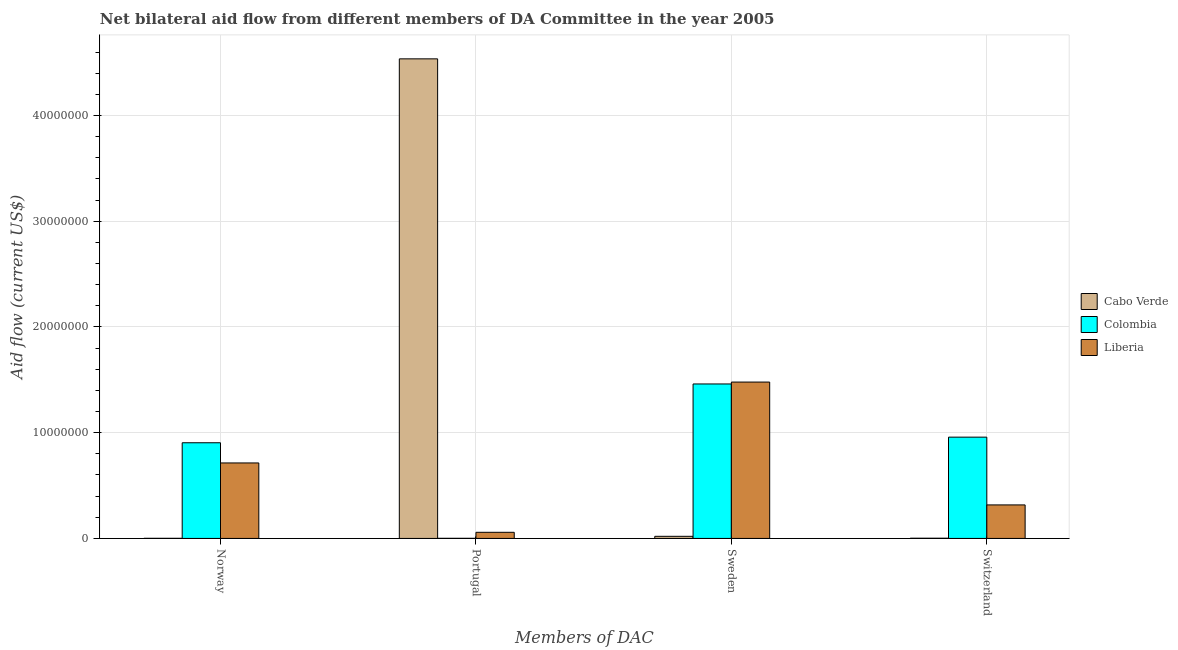Are the number of bars per tick equal to the number of legend labels?
Your answer should be compact. Yes. What is the label of the 4th group of bars from the left?
Ensure brevity in your answer.  Switzerland. What is the amount of aid given by sweden in Colombia?
Your answer should be very brief. 1.46e+07. Across all countries, what is the maximum amount of aid given by sweden?
Keep it short and to the point. 1.48e+07. Across all countries, what is the minimum amount of aid given by sweden?
Your answer should be compact. 2.00e+05. In which country was the amount of aid given by portugal maximum?
Offer a terse response. Cabo Verde. What is the total amount of aid given by sweden in the graph?
Give a very brief answer. 2.96e+07. What is the difference between the amount of aid given by sweden in Liberia and that in Cabo Verde?
Ensure brevity in your answer.  1.46e+07. What is the difference between the amount of aid given by switzerland in Colombia and the amount of aid given by sweden in Cabo Verde?
Provide a succinct answer. 9.38e+06. What is the average amount of aid given by portugal per country?
Make the answer very short. 1.53e+07. What is the difference between the amount of aid given by portugal and amount of aid given by norway in Cabo Verde?
Your answer should be very brief. 4.54e+07. In how many countries, is the amount of aid given by norway greater than 30000000 US$?
Give a very brief answer. 0. What is the ratio of the amount of aid given by portugal in Cabo Verde to that in Liberia?
Your response must be concise. 78.21. Is the amount of aid given by switzerland in Liberia less than that in Cabo Verde?
Your answer should be very brief. No. What is the difference between the highest and the second highest amount of aid given by sweden?
Provide a short and direct response. 1.80e+05. What is the difference between the highest and the lowest amount of aid given by portugal?
Your answer should be very brief. 4.54e+07. In how many countries, is the amount of aid given by sweden greater than the average amount of aid given by sweden taken over all countries?
Your response must be concise. 2. Is the sum of the amount of aid given by norway in Colombia and Liberia greater than the maximum amount of aid given by switzerland across all countries?
Ensure brevity in your answer.  Yes. What does the 3rd bar from the left in Sweden represents?
Offer a terse response. Liberia. What does the 3rd bar from the right in Sweden represents?
Make the answer very short. Cabo Verde. How many bars are there?
Your response must be concise. 12. Are all the bars in the graph horizontal?
Offer a very short reply. No. How many countries are there in the graph?
Provide a short and direct response. 3. What is the difference between two consecutive major ticks on the Y-axis?
Ensure brevity in your answer.  1.00e+07. Are the values on the major ticks of Y-axis written in scientific E-notation?
Your answer should be compact. No. Where does the legend appear in the graph?
Provide a succinct answer. Center right. How many legend labels are there?
Provide a short and direct response. 3. How are the legend labels stacked?
Provide a short and direct response. Vertical. What is the title of the graph?
Your answer should be very brief. Net bilateral aid flow from different members of DA Committee in the year 2005. What is the label or title of the X-axis?
Offer a very short reply. Members of DAC. What is the Aid flow (current US$) in Colombia in Norway?
Keep it short and to the point. 9.05e+06. What is the Aid flow (current US$) of Liberia in Norway?
Your response must be concise. 7.14e+06. What is the Aid flow (current US$) in Cabo Verde in Portugal?
Provide a succinct answer. 4.54e+07. What is the Aid flow (current US$) in Liberia in Portugal?
Ensure brevity in your answer.  5.80e+05. What is the Aid flow (current US$) of Colombia in Sweden?
Your response must be concise. 1.46e+07. What is the Aid flow (current US$) of Liberia in Sweden?
Your response must be concise. 1.48e+07. What is the Aid flow (current US$) of Cabo Verde in Switzerland?
Your answer should be compact. 2.00e+04. What is the Aid flow (current US$) in Colombia in Switzerland?
Keep it short and to the point. 9.58e+06. What is the Aid flow (current US$) in Liberia in Switzerland?
Make the answer very short. 3.17e+06. Across all Members of DAC, what is the maximum Aid flow (current US$) of Cabo Verde?
Your response must be concise. 4.54e+07. Across all Members of DAC, what is the maximum Aid flow (current US$) in Colombia?
Your answer should be very brief. 1.46e+07. Across all Members of DAC, what is the maximum Aid flow (current US$) in Liberia?
Provide a succinct answer. 1.48e+07. Across all Members of DAC, what is the minimum Aid flow (current US$) of Cabo Verde?
Your answer should be compact. 10000. Across all Members of DAC, what is the minimum Aid flow (current US$) in Colombia?
Keep it short and to the point. 10000. Across all Members of DAC, what is the minimum Aid flow (current US$) in Liberia?
Offer a terse response. 5.80e+05. What is the total Aid flow (current US$) in Cabo Verde in the graph?
Keep it short and to the point. 4.56e+07. What is the total Aid flow (current US$) of Colombia in the graph?
Your answer should be very brief. 3.32e+07. What is the total Aid flow (current US$) of Liberia in the graph?
Your answer should be very brief. 2.57e+07. What is the difference between the Aid flow (current US$) of Cabo Verde in Norway and that in Portugal?
Your answer should be very brief. -4.54e+07. What is the difference between the Aid flow (current US$) in Colombia in Norway and that in Portugal?
Offer a very short reply. 9.04e+06. What is the difference between the Aid flow (current US$) of Liberia in Norway and that in Portugal?
Keep it short and to the point. 6.56e+06. What is the difference between the Aid flow (current US$) in Cabo Verde in Norway and that in Sweden?
Your answer should be very brief. -1.90e+05. What is the difference between the Aid flow (current US$) in Colombia in Norway and that in Sweden?
Make the answer very short. -5.56e+06. What is the difference between the Aid flow (current US$) in Liberia in Norway and that in Sweden?
Keep it short and to the point. -7.65e+06. What is the difference between the Aid flow (current US$) in Colombia in Norway and that in Switzerland?
Provide a short and direct response. -5.30e+05. What is the difference between the Aid flow (current US$) of Liberia in Norway and that in Switzerland?
Give a very brief answer. 3.97e+06. What is the difference between the Aid flow (current US$) in Cabo Verde in Portugal and that in Sweden?
Your response must be concise. 4.52e+07. What is the difference between the Aid flow (current US$) in Colombia in Portugal and that in Sweden?
Make the answer very short. -1.46e+07. What is the difference between the Aid flow (current US$) of Liberia in Portugal and that in Sweden?
Keep it short and to the point. -1.42e+07. What is the difference between the Aid flow (current US$) in Cabo Verde in Portugal and that in Switzerland?
Give a very brief answer. 4.53e+07. What is the difference between the Aid flow (current US$) of Colombia in Portugal and that in Switzerland?
Provide a succinct answer. -9.57e+06. What is the difference between the Aid flow (current US$) in Liberia in Portugal and that in Switzerland?
Your answer should be compact. -2.59e+06. What is the difference between the Aid flow (current US$) of Colombia in Sweden and that in Switzerland?
Provide a short and direct response. 5.03e+06. What is the difference between the Aid flow (current US$) in Liberia in Sweden and that in Switzerland?
Ensure brevity in your answer.  1.16e+07. What is the difference between the Aid flow (current US$) of Cabo Verde in Norway and the Aid flow (current US$) of Liberia in Portugal?
Your answer should be compact. -5.70e+05. What is the difference between the Aid flow (current US$) in Colombia in Norway and the Aid flow (current US$) in Liberia in Portugal?
Make the answer very short. 8.47e+06. What is the difference between the Aid flow (current US$) in Cabo Verde in Norway and the Aid flow (current US$) in Colombia in Sweden?
Offer a terse response. -1.46e+07. What is the difference between the Aid flow (current US$) of Cabo Verde in Norway and the Aid flow (current US$) of Liberia in Sweden?
Offer a very short reply. -1.48e+07. What is the difference between the Aid flow (current US$) of Colombia in Norway and the Aid flow (current US$) of Liberia in Sweden?
Ensure brevity in your answer.  -5.74e+06. What is the difference between the Aid flow (current US$) in Cabo Verde in Norway and the Aid flow (current US$) in Colombia in Switzerland?
Make the answer very short. -9.57e+06. What is the difference between the Aid flow (current US$) in Cabo Verde in Norway and the Aid flow (current US$) in Liberia in Switzerland?
Offer a terse response. -3.16e+06. What is the difference between the Aid flow (current US$) of Colombia in Norway and the Aid flow (current US$) of Liberia in Switzerland?
Provide a short and direct response. 5.88e+06. What is the difference between the Aid flow (current US$) of Cabo Verde in Portugal and the Aid flow (current US$) of Colombia in Sweden?
Make the answer very short. 3.08e+07. What is the difference between the Aid flow (current US$) in Cabo Verde in Portugal and the Aid flow (current US$) in Liberia in Sweden?
Offer a very short reply. 3.06e+07. What is the difference between the Aid flow (current US$) in Colombia in Portugal and the Aid flow (current US$) in Liberia in Sweden?
Ensure brevity in your answer.  -1.48e+07. What is the difference between the Aid flow (current US$) in Cabo Verde in Portugal and the Aid flow (current US$) in Colombia in Switzerland?
Your answer should be compact. 3.58e+07. What is the difference between the Aid flow (current US$) of Cabo Verde in Portugal and the Aid flow (current US$) of Liberia in Switzerland?
Keep it short and to the point. 4.22e+07. What is the difference between the Aid flow (current US$) of Colombia in Portugal and the Aid flow (current US$) of Liberia in Switzerland?
Give a very brief answer. -3.16e+06. What is the difference between the Aid flow (current US$) of Cabo Verde in Sweden and the Aid flow (current US$) of Colombia in Switzerland?
Provide a short and direct response. -9.38e+06. What is the difference between the Aid flow (current US$) of Cabo Verde in Sweden and the Aid flow (current US$) of Liberia in Switzerland?
Ensure brevity in your answer.  -2.97e+06. What is the difference between the Aid flow (current US$) of Colombia in Sweden and the Aid flow (current US$) of Liberia in Switzerland?
Your response must be concise. 1.14e+07. What is the average Aid flow (current US$) of Cabo Verde per Members of DAC?
Ensure brevity in your answer.  1.14e+07. What is the average Aid flow (current US$) in Colombia per Members of DAC?
Give a very brief answer. 8.31e+06. What is the average Aid flow (current US$) in Liberia per Members of DAC?
Ensure brevity in your answer.  6.42e+06. What is the difference between the Aid flow (current US$) of Cabo Verde and Aid flow (current US$) of Colombia in Norway?
Offer a very short reply. -9.04e+06. What is the difference between the Aid flow (current US$) of Cabo Verde and Aid flow (current US$) of Liberia in Norway?
Give a very brief answer. -7.13e+06. What is the difference between the Aid flow (current US$) in Colombia and Aid flow (current US$) in Liberia in Norway?
Provide a succinct answer. 1.91e+06. What is the difference between the Aid flow (current US$) of Cabo Verde and Aid flow (current US$) of Colombia in Portugal?
Make the answer very short. 4.54e+07. What is the difference between the Aid flow (current US$) of Cabo Verde and Aid flow (current US$) of Liberia in Portugal?
Provide a short and direct response. 4.48e+07. What is the difference between the Aid flow (current US$) in Colombia and Aid flow (current US$) in Liberia in Portugal?
Offer a very short reply. -5.70e+05. What is the difference between the Aid flow (current US$) in Cabo Verde and Aid flow (current US$) in Colombia in Sweden?
Your answer should be compact. -1.44e+07. What is the difference between the Aid flow (current US$) of Cabo Verde and Aid flow (current US$) of Liberia in Sweden?
Offer a terse response. -1.46e+07. What is the difference between the Aid flow (current US$) in Cabo Verde and Aid flow (current US$) in Colombia in Switzerland?
Offer a terse response. -9.56e+06. What is the difference between the Aid flow (current US$) in Cabo Verde and Aid flow (current US$) in Liberia in Switzerland?
Give a very brief answer. -3.15e+06. What is the difference between the Aid flow (current US$) of Colombia and Aid flow (current US$) of Liberia in Switzerland?
Give a very brief answer. 6.41e+06. What is the ratio of the Aid flow (current US$) in Colombia in Norway to that in Portugal?
Make the answer very short. 905. What is the ratio of the Aid flow (current US$) in Liberia in Norway to that in Portugal?
Your response must be concise. 12.31. What is the ratio of the Aid flow (current US$) in Cabo Verde in Norway to that in Sweden?
Your response must be concise. 0.05. What is the ratio of the Aid flow (current US$) in Colombia in Norway to that in Sweden?
Provide a short and direct response. 0.62. What is the ratio of the Aid flow (current US$) of Liberia in Norway to that in Sweden?
Make the answer very short. 0.48. What is the ratio of the Aid flow (current US$) in Colombia in Norway to that in Switzerland?
Offer a terse response. 0.94. What is the ratio of the Aid flow (current US$) in Liberia in Norway to that in Switzerland?
Provide a short and direct response. 2.25. What is the ratio of the Aid flow (current US$) in Cabo Verde in Portugal to that in Sweden?
Your answer should be compact. 226.8. What is the ratio of the Aid flow (current US$) in Colombia in Portugal to that in Sweden?
Make the answer very short. 0. What is the ratio of the Aid flow (current US$) in Liberia in Portugal to that in Sweden?
Your answer should be very brief. 0.04. What is the ratio of the Aid flow (current US$) in Cabo Verde in Portugal to that in Switzerland?
Make the answer very short. 2268. What is the ratio of the Aid flow (current US$) of Liberia in Portugal to that in Switzerland?
Keep it short and to the point. 0.18. What is the ratio of the Aid flow (current US$) in Colombia in Sweden to that in Switzerland?
Keep it short and to the point. 1.53. What is the ratio of the Aid flow (current US$) in Liberia in Sweden to that in Switzerland?
Provide a short and direct response. 4.67. What is the difference between the highest and the second highest Aid flow (current US$) in Cabo Verde?
Ensure brevity in your answer.  4.52e+07. What is the difference between the highest and the second highest Aid flow (current US$) in Colombia?
Your answer should be very brief. 5.03e+06. What is the difference between the highest and the second highest Aid flow (current US$) in Liberia?
Keep it short and to the point. 7.65e+06. What is the difference between the highest and the lowest Aid flow (current US$) in Cabo Verde?
Provide a short and direct response. 4.54e+07. What is the difference between the highest and the lowest Aid flow (current US$) in Colombia?
Offer a terse response. 1.46e+07. What is the difference between the highest and the lowest Aid flow (current US$) in Liberia?
Give a very brief answer. 1.42e+07. 